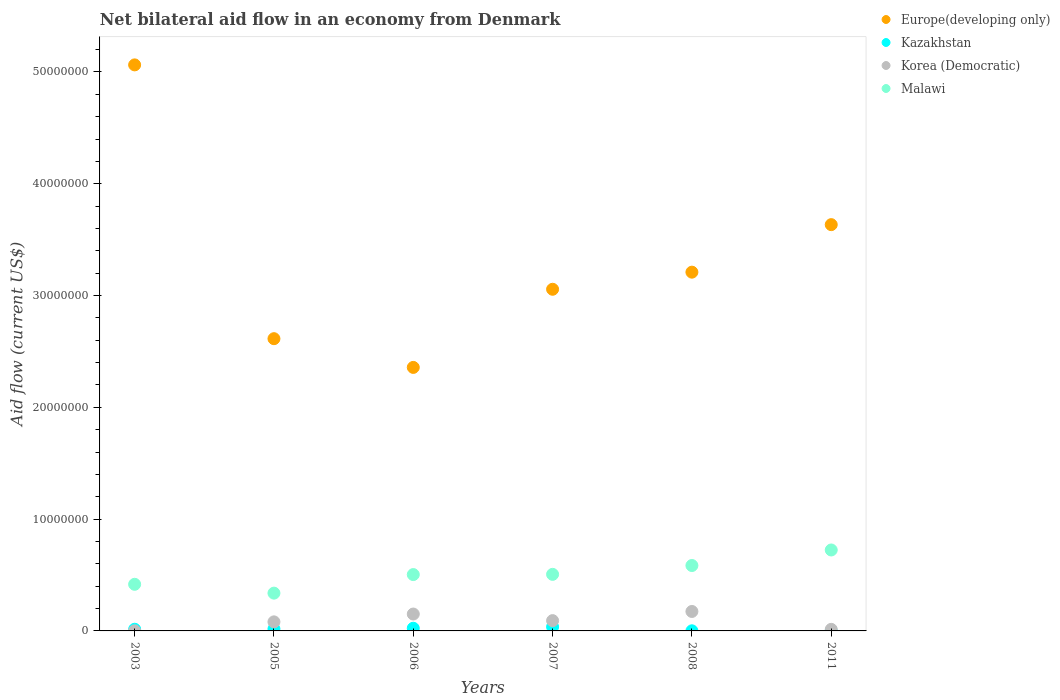What is the net bilateral aid flow in Malawi in 2007?
Your answer should be compact. 5.06e+06. Across all years, what is the maximum net bilateral aid flow in Malawi?
Keep it short and to the point. 7.24e+06. Across all years, what is the minimum net bilateral aid flow in Malawi?
Offer a terse response. 3.38e+06. What is the total net bilateral aid flow in Malawi in the graph?
Your answer should be compact. 3.07e+07. What is the difference between the net bilateral aid flow in Korea (Democratic) in 2003 and that in 2006?
Keep it short and to the point. -1.50e+06. What is the difference between the net bilateral aid flow in Malawi in 2003 and the net bilateral aid flow in Europe(developing only) in 2005?
Make the answer very short. -2.20e+07. What is the average net bilateral aid flow in Korea (Democratic) per year?
Give a very brief answer. 8.55e+05. In the year 2003, what is the difference between the net bilateral aid flow in Europe(developing only) and net bilateral aid flow in Korea (Democratic)?
Ensure brevity in your answer.  5.06e+07. In how many years, is the net bilateral aid flow in Malawi greater than 32000000 US$?
Offer a very short reply. 0. What is the ratio of the net bilateral aid flow in Europe(developing only) in 2006 to that in 2008?
Your answer should be compact. 0.73. Is the net bilateral aid flow in Kazakhstan in 2003 less than that in 2006?
Your response must be concise. Yes. Is the difference between the net bilateral aid flow in Europe(developing only) in 2008 and 2011 greater than the difference between the net bilateral aid flow in Korea (Democratic) in 2008 and 2011?
Your answer should be compact. No. What is the difference between the highest and the second highest net bilateral aid flow in Malawi?
Give a very brief answer. 1.39e+06. What is the difference between the highest and the lowest net bilateral aid flow in Korea (Democratic)?
Provide a short and direct response. 1.73e+06. Is the sum of the net bilateral aid flow in Korea (Democratic) in 2007 and 2008 greater than the maximum net bilateral aid flow in Kazakhstan across all years?
Offer a very short reply. Yes. Is it the case that in every year, the sum of the net bilateral aid flow in Korea (Democratic) and net bilateral aid flow in Malawi  is greater than the net bilateral aid flow in Kazakhstan?
Provide a short and direct response. Yes. How many dotlines are there?
Your answer should be compact. 4. How many years are there in the graph?
Your answer should be very brief. 6. What is the difference between two consecutive major ticks on the Y-axis?
Your answer should be very brief. 1.00e+07. Does the graph contain any zero values?
Keep it short and to the point. Yes. How are the legend labels stacked?
Offer a terse response. Vertical. What is the title of the graph?
Your answer should be compact. Net bilateral aid flow in an economy from Denmark. Does "Suriname" appear as one of the legend labels in the graph?
Make the answer very short. No. What is the label or title of the X-axis?
Provide a short and direct response. Years. What is the label or title of the Y-axis?
Provide a short and direct response. Aid flow (current US$). What is the Aid flow (current US$) of Europe(developing only) in 2003?
Your answer should be very brief. 5.06e+07. What is the Aid flow (current US$) of Malawi in 2003?
Your response must be concise. 4.17e+06. What is the Aid flow (current US$) in Europe(developing only) in 2005?
Offer a very short reply. 2.61e+07. What is the Aid flow (current US$) in Korea (Democratic) in 2005?
Your response must be concise. 8.10e+05. What is the Aid flow (current US$) of Malawi in 2005?
Your answer should be compact. 3.38e+06. What is the Aid flow (current US$) in Europe(developing only) in 2006?
Your answer should be very brief. 2.36e+07. What is the Aid flow (current US$) of Kazakhstan in 2006?
Offer a terse response. 2.40e+05. What is the Aid flow (current US$) of Korea (Democratic) in 2006?
Your response must be concise. 1.51e+06. What is the Aid flow (current US$) in Malawi in 2006?
Your answer should be very brief. 5.04e+06. What is the Aid flow (current US$) of Europe(developing only) in 2007?
Offer a very short reply. 3.06e+07. What is the Aid flow (current US$) of Kazakhstan in 2007?
Offer a very short reply. 3.60e+05. What is the Aid flow (current US$) of Korea (Democratic) in 2007?
Offer a very short reply. 9.20e+05. What is the Aid flow (current US$) of Malawi in 2007?
Make the answer very short. 5.06e+06. What is the Aid flow (current US$) in Europe(developing only) in 2008?
Provide a succinct answer. 3.21e+07. What is the Aid flow (current US$) in Kazakhstan in 2008?
Ensure brevity in your answer.  10000. What is the Aid flow (current US$) in Korea (Democratic) in 2008?
Provide a short and direct response. 1.74e+06. What is the Aid flow (current US$) of Malawi in 2008?
Offer a very short reply. 5.85e+06. What is the Aid flow (current US$) in Europe(developing only) in 2011?
Offer a terse response. 3.63e+07. What is the Aid flow (current US$) of Malawi in 2011?
Your response must be concise. 7.24e+06. Across all years, what is the maximum Aid flow (current US$) of Europe(developing only)?
Offer a terse response. 5.06e+07. Across all years, what is the maximum Aid flow (current US$) of Korea (Democratic)?
Provide a short and direct response. 1.74e+06. Across all years, what is the maximum Aid flow (current US$) in Malawi?
Your answer should be compact. 7.24e+06. Across all years, what is the minimum Aid flow (current US$) in Europe(developing only)?
Give a very brief answer. 2.36e+07. Across all years, what is the minimum Aid flow (current US$) of Kazakhstan?
Your answer should be compact. 0. Across all years, what is the minimum Aid flow (current US$) in Korea (Democratic)?
Offer a terse response. 10000. Across all years, what is the minimum Aid flow (current US$) of Malawi?
Keep it short and to the point. 3.38e+06. What is the total Aid flow (current US$) of Europe(developing only) in the graph?
Ensure brevity in your answer.  1.99e+08. What is the total Aid flow (current US$) of Kazakhstan in the graph?
Make the answer very short. 9.40e+05. What is the total Aid flow (current US$) of Korea (Democratic) in the graph?
Provide a short and direct response. 5.13e+06. What is the total Aid flow (current US$) of Malawi in the graph?
Provide a succinct answer. 3.07e+07. What is the difference between the Aid flow (current US$) of Europe(developing only) in 2003 and that in 2005?
Your response must be concise. 2.45e+07. What is the difference between the Aid flow (current US$) of Korea (Democratic) in 2003 and that in 2005?
Ensure brevity in your answer.  -8.00e+05. What is the difference between the Aid flow (current US$) of Malawi in 2003 and that in 2005?
Your response must be concise. 7.90e+05. What is the difference between the Aid flow (current US$) of Europe(developing only) in 2003 and that in 2006?
Give a very brief answer. 2.71e+07. What is the difference between the Aid flow (current US$) in Korea (Democratic) in 2003 and that in 2006?
Ensure brevity in your answer.  -1.50e+06. What is the difference between the Aid flow (current US$) in Malawi in 2003 and that in 2006?
Provide a short and direct response. -8.70e+05. What is the difference between the Aid flow (current US$) in Europe(developing only) in 2003 and that in 2007?
Offer a terse response. 2.01e+07. What is the difference between the Aid flow (current US$) in Kazakhstan in 2003 and that in 2007?
Your response must be concise. -2.10e+05. What is the difference between the Aid flow (current US$) in Korea (Democratic) in 2003 and that in 2007?
Your answer should be compact. -9.10e+05. What is the difference between the Aid flow (current US$) of Malawi in 2003 and that in 2007?
Provide a succinct answer. -8.90e+05. What is the difference between the Aid flow (current US$) of Europe(developing only) in 2003 and that in 2008?
Provide a short and direct response. 1.85e+07. What is the difference between the Aid flow (current US$) of Kazakhstan in 2003 and that in 2008?
Offer a terse response. 1.40e+05. What is the difference between the Aid flow (current US$) of Korea (Democratic) in 2003 and that in 2008?
Make the answer very short. -1.73e+06. What is the difference between the Aid flow (current US$) in Malawi in 2003 and that in 2008?
Offer a very short reply. -1.68e+06. What is the difference between the Aid flow (current US$) of Europe(developing only) in 2003 and that in 2011?
Your answer should be compact. 1.43e+07. What is the difference between the Aid flow (current US$) in Malawi in 2003 and that in 2011?
Give a very brief answer. -3.07e+06. What is the difference between the Aid flow (current US$) in Europe(developing only) in 2005 and that in 2006?
Give a very brief answer. 2.57e+06. What is the difference between the Aid flow (current US$) of Korea (Democratic) in 2005 and that in 2006?
Provide a short and direct response. -7.00e+05. What is the difference between the Aid flow (current US$) of Malawi in 2005 and that in 2006?
Provide a short and direct response. -1.66e+06. What is the difference between the Aid flow (current US$) of Europe(developing only) in 2005 and that in 2007?
Provide a succinct answer. -4.42e+06. What is the difference between the Aid flow (current US$) in Kazakhstan in 2005 and that in 2007?
Give a very brief answer. -1.80e+05. What is the difference between the Aid flow (current US$) of Malawi in 2005 and that in 2007?
Provide a succinct answer. -1.68e+06. What is the difference between the Aid flow (current US$) in Europe(developing only) in 2005 and that in 2008?
Ensure brevity in your answer.  -5.95e+06. What is the difference between the Aid flow (current US$) in Korea (Democratic) in 2005 and that in 2008?
Your response must be concise. -9.30e+05. What is the difference between the Aid flow (current US$) in Malawi in 2005 and that in 2008?
Ensure brevity in your answer.  -2.47e+06. What is the difference between the Aid flow (current US$) in Europe(developing only) in 2005 and that in 2011?
Your answer should be very brief. -1.02e+07. What is the difference between the Aid flow (current US$) in Korea (Democratic) in 2005 and that in 2011?
Make the answer very short. 6.70e+05. What is the difference between the Aid flow (current US$) in Malawi in 2005 and that in 2011?
Make the answer very short. -3.86e+06. What is the difference between the Aid flow (current US$) of Europe(developing only) in 2006 and that in 2007?
Your answer should be compact. -6.99e+06. What is the difference between the Aid flow (current US$) of Kazakhstan in 2006 and that in 2007?
Give a very brief answer. -1.20e+05. What is the difference between the Aid flow (current US$) in Korea (Democratic) in 2006 and that in 2007?
Give a very brief answer. 5.90e+05. What is the difference between the Aid flow (current US$) of Malawi in 2006 and that in 2007?
Offer a terse response. -2.00e+04. What is the difference between the Aid flow (current US$) in Europe(developing only) in 2006 and that in 2008?
Keep it short and to the point. -8.52e+06. What is the difference between the Aid flow (current US$) of Kazakhstan in 2006 and that in 2008?
Your answer should be compact. 2.30e+05. What is the difference between the Aid flow (current US$) in Korea (Democratic) in 2006 and that in 2008?
Make the answer very short. -2.30e+05. What is the difference between the Aid flow (current US$) of Malawi in 2006 and that in 2008?
Offer a very short reply. -8.10e+05. What is the difference between the Aid flow (current US$) of Europe(developing only) in 2006 and that in 2011?
Your answer should be compact. -1.28e+07. What is the difference between the Aid flow (current US$) of Korea (Democratic) in 2006 and that in 2011?
Provide a succinct answer. 1.37e+06. What is the difference between the Aid flow (current US$) in Malawi in 2006 and that in 2011?
Offer a terse response. -2.20e+06. What is the difference between the Aid flow (current US$) in Europe(developing only) in 2007 and that in 2008?
Keep it short and to the point. -1.53e+06. What is the difference between the Aid flow (current US$) in Kazakhstan in 2007 and that in 2008?
Provide a succinct answer. 3.50e+05. What is the difference between the Aid flow (current US$) of Korea (Democratic) in 2007 and that in 2008?
Ensure brevity in your answer.  -8.20e+05. What is the difference between the Aid flow (current US$) in Malawi in 2007 and that in 2008?
Your answer should be compact. -7.90e+05. What is the difference between the Aid flow (current US$) in Europe(developing only) in 2007 and that in 2011?
Offer a terse response. -5.78e+06. What is the difference between the Aid flow (current US$) in Korea (Democratic) in 2007 and that in 2011?
Give a very brief answer. 7.80e+05. What is the difference between the Aid flow (current US$) in Malawi in 2007 and that in 2011?
Provide a short and direct response. -2.18e+06. What is the difference between the Aid flow (current US$) in Europe(developing only) in 2008 and that in 2011?
Make the answer very short. -4.25e+06. What is the difference between the Aid flow (current US$) of Korea (Democratic) in 2008 and that in 2011?
Your answer should be compact. 1.60e+06. What is the difference between the Aid flow (current US$) of Malawi in 2008 and that in 2011?
Make the answer very short. -1.39e+06. What is the difference between the Aid flow (current US$) in Europe(developing only) in 2003 and the Aid flow (current US$) in Kazakhstan in 2005?
Offer a very short reply. 5.04e+07. What is the difference between the Aid flow (current US$) of Europe(developing only) in 2003 and the Aid flow (current US$) of Korea (Democratic) in 2005?
Your answer should be compact. 4.98e+07. What is the difference between the Aid flow (current US$) of Europe(developing only) in 2003 and the Aid flow (current US$) of Malawi in 2005?
Your response must be concise. 4.72e+07. What is the difference between the Aid flow (current US$) of Kazakhstan in 2003 and the Aid flow (current US$) of Korea (Democratic) in 2005?
Offer a very short reply. -6.60e+05. What is the difference between the Aid flow (current US$) of Kazakhstan in 2003 and the Aid flow (current US$) of Malawi in 2005?
Keep it short and to the point. -3.23e+06. What is the difference between the Aid flow (current US$) of Korea (Democratic) in 2003 and the Aid flow (current US$) of Malawi in 2005?
Your answer should be compact. -3.37e+06. What is the difference between the Aid flow (current US$) of Europe(developing only) in 2003 and the Aid flow (current US$) of Kazakhstan in 2006?
Make the answer very short. 5.04e+07. What is the difference between the Aid flow (current US$) in Europe(developing only) in 2003 and the Aid flow (current US$) in Korea (Democratic) in 2006?
Provide a short and direct response. 4.91e+07. What is the difference between the Aid flow (current US$) of Europe(developing only) in 2003 and the Aid flow (current US$) of Malawi in 2006?
Make the answer very short. 4.56e+07. What is the difference between the Aid flow (current US$) of Kazakhstan in 2003 and the Aid flow (current US$) of Korea (Democratic) in 2006?
Give a very brief answer. -1.36e+06. What is the difference between the Aid flow (current US$) in Kazakhstan in 2003 and the Aid flow (current US$) in Malawi in 2006?
Give a very brief answer. -4.89e+06. What is the difference between the Aid flow (current US$) of Korea (Democratic) in 2003 and the Aid flow (current US$) of Malawi in 2006?
Keep it short and to the point. -5.03e+06. What is the difference between the Aid flow (current US$) of Europe(developing only) in 2003 and the Aid flow (current US$) of Kazakhstan in 2007?
Keep it short and to the point. 5.03e+07. What is the difference between the Aid flow (current US$) in Europe(developing only) in 2003 and the Aid flow (current US$) in Korea (Democratic) in 2007?
Give a very brief answer. 4.97e+07. What is the difference between the Aid flow (current US$) of Europe(developing only) in 2003 and the Aid flow (current US$) of Malawi in 2007?
Your answer should be compact. 4.56e+07. What is the difference between the Aid flow (current US$) of Kazakhstan in 2003 and the Aid flow (current US$) of Korea (Democratic) in 2007?
Your answer should be compact. -7.70e+05. What is the difference between the Aid flow (current US$) of Kazakhstan in 2003 and the Aid flow (current US$) of Malawi in 2007?
Offer a very short reply. -4.91e+06. What is the difference between the Aid flow (current US$) in Korea (Democratic) in 2003 and the Aid flow (current US$) in Malawi in 2007?
Offer a terse response. -5.05e+06. What is the difference between the Aid flow (current US$) in Europe(developing only) in 2003 and the Aid flow (current US$) in Kazakhstan in 2008?
Offer a terse response. 5.06e+07. What is the difference between the Aid flow (current US$) in Europe(developing only) in 2003 and the Aid flow (current US$) in Korea (Democratic) in 2008?
Your response must be concise. 4.89e+07. What is the difference between the Aid flow (current US$) in Europe(developing only) in 2003 and the Aid flow (current US$) in Malawi in 2008?
Provide a short and direct response. 4.48e+07. What is the difference between the Aid flow (current US$) in Kazakhstan in 2003 and the Aid flow (current US$) in Korea (Democratic) in 2008?
Your answer should be compact. -1.59e+06. What is the difference between the Aid flow (current US$) in Kazakhstan in 2003 and the Aid flow (current US$) in Malawi in 2008?
Keep it short and to the point. -5.70e+06. What is the difference between the Aid flow (current US$) in Korea (Democratic) in 2003 and the Aid flow (current US$) in Malawi in 2008?
Your answer should be compact. -5.84e+06. What is the difference between the Aid flow (current US$) of Europe(developing only) in 2003 and the Aid flow (current US$) of Korea (Democratic) in 2011?
Your answer should be very brief. 5.05e+07. What is the difference between the Aid flow (current US$) in Europe(developing only) in 2003 and the Aid flow (current US$) in Malawi in 2011?
Provide a succinct answer. 4.34e+07. What is the difference between the Aid flow (current US$) of Kazakhstan in 2003 and the Aid flow (current US$) of Korea (Democratic) in 2011?
Offer a terse response. 10000. What is the difference between the Aid flow (current US$) of Kazakhstan in 2003 and the Aid flow (current US$) of Malawi in 2011?
Keep it short and to the point. -7.09e+06. What is the difference between the Aid flow (current US$) in Korea (Democratic) in 2003 and the Aid flow (current US$) in Malawi in 2011?
Ensure brevity in your answer.  -7.23e+06. What is the difference between the Aid flow (current US$) of Europe(developing only) in 2005 and the Aid flow (current US$) of Kazakhstan in 2006?
Give a very brief answer. 2.59e+07. What is the difference between the Aid flow (current US$) of Europe(developing only) in 2005 and the Aid flow (current US$) of Korea (Democratic) in 2006?
Your response must be concise. 2.46e+07. What is the difference between the Aid flow (current US$) in Europe(developing only) in 2005 and the Aid flow (current US$) in Malawi in 2006?
Make the answer very short. 2.11e+07. What is the difference between the Aid flow (current US$) of Kazakhstan in 2005 and the Aid flow (current US$) of Korea (Democratic) in 2006?
Offer a very short reply. -1.33e+06. What is the difference between the Aid flow (current US$) in Kazakhstan in 2005 and the Aid flow (current US$) in Malawi in 2006?
Make the answer very short. -4.86e+06. What is the difference between the Aid flow (current US$) in Korea (Democratic) in 2005 and the Aid flow (current US$) in Malawi in 2006?
Your answer should be very brief. -4.23e+06. What is the difference between the Aid flow (current US$) of Europe(developing only) in 2005 and the Aid flow (current US$) of Kazakhstan in 2007?
Keep it short and to the point. 2.58e+07. What is the difference between the Aid flow (current US$) of Europe(developing only) in 2005 and the Aid flow (current US$) of Korea (Democratic) in 2007?
Your answer should be very brief. 2.52e+07. What is the difference between the Aid flow (current US$) of Europe(developing only) in 2005 and the Aid flow (current US$) of Malawi in 2007?
Your answer should be very brief. 2.11e+07. What is the difference between the Aid flow (current US$) of Kazakhstan in 2005 and the Aid flow (current US$) of Korea (Democratic) in 2007?
Your answer should be compact. -7.40e+05. What is the difference between the Aid flow (current US$) in Kazakhstan in 2005 and the Aid flow (current US$) in Malawi in 2007?
Keep it short and to the point. -4.88e+06. What is the difference between the Aid flow (current US$) in Korea (Democratic) in 2005 and the Aid flow (current US$) in Malawi in 2007?
Provide a short and direct response. -4.25e+06. What is the difference between the Aid flow (current US$) in Europe(developing only) in 2005 and the Aid flow (current US$) in Kazakhstan in 2008?
Provide a succinct answer. 2.61e+07. What is the difference between the Aid flow (current US$) in Europe(developing only) in 2005 and the Aid flow (current US$) in Korea (Democratic) in 2008?
Give a very brief answer. 2.44e+07. What is the difference between the Aid flow (current US$) in Europe(developing only) in 2005 and the Aid flow (current US$) in Malawi in 2008?
Offer a very short reply. 2.03e+07. What is the difference between the Aid flow (current US$) of Kazakhstan in 2005 and the Aid flow (current US$) of Korea (Democratic) in 2008?
Provide a short and direct response. -1.56e+06. What is the difference between the Aid flow (current US$) in Kazakhstan in 2005 and the Aid flow (current US$) in Malawi in 2008?
Provide a short and direct response. -5.67e+06. What is the difference between the Aid flow (current US$) of Korea (Democratic) in 2005 and the Aid flow (current US$) of Malawi in 2008?
Offer a terse response. -5.04e+06. What is the difference between the Aid flow (current US$) in Europe(developing only) in 2005 and the Aid flow (current US$) in Korea (Democratic) in 2011?
Offer a very short reply. 2.60e+07. What is the difference between the Aid flow (current US$) in Europe(developing only) in 2005 and the Aid flow (current US$) in Malawi in 2011?
Provide a short and direct response. 1.89e+07. What is the difference between the Aid flow (current US$) in Kazakhstan in 2005 and the Aid flow (current US$) in Malawi in 2011?
Give a very brief answer. -7.06e+06. What is the difference between the Aid flow (current US$) of Korea (Democratic) in 2005 and the Aid flow (current US$) of Malawi in 2011?
Your answer should be very brief. -6.43e+06. What is the difference between the Aid flow (current US$) of Europe(developing only) in 2006 and the Aid flow (current US$) of Kazakhstan in 2007?
Ensure brevity in your answer.  2.32e+07. What is the difference between the Aid flow (current US$) of Europe(developing only) in 2006 and the Aid flow (current US$) of Korea (Democratic) in 2007?
Keep it short and to the point. 2.26e+07. What is the difference between the Aid flow (current US$) in Europe(developing only) in 2006 and the Aid flow (current US$) in Malawi in 2007?
Your answer should be very brief. 1.85e+07. What is the difference between the Aid flow (current US$) in Kazakhstan in 2006 and the Aid flow (current US$) in Korea (Democratic) in 2007?
Your answer should be compact. -6.80e+05. What is the difference between the Aid flow (current US$) in Kazakhstan in 2006 and the Aid flow (current US$) in Malawi in 2007?
Your answer should be compact. -4.82e+06. What is the difference between the Aid flow (current US$) in Korea (Democratic) in 2006 and the Aid flow (current US$) in Malawi in 2007?
Ensure brevity in your answer.  -3.55e+06. What is the difference between the Aid flow (current US$) of Europe(developing only) in 2006 and the Aid flow (current US$) of Kazakhstan in 2008?
Make the answer very short. 2.36e+07. What is the difference between the Aid flow (current US$) of Europe(developing only) in 2006 and the Aid flow (current US$) of Korea (Democratic) in 2008?
Offer a very short reply. 2.18e+07. What is the difference between the Aid flow (current US$) of Europe(developing only) in 2006 and the Aid flow (current US$) of Malawi in 2008?
Your answer should be compact. 1.77e+07. What is the difference between the Aid flow (current US$) of Kazakhstan in 2006 and the Aid flow (current US$) of Korea (Democratic) in 2008?
Your answer should be very brief. -1.50e+06. What is the difference between the Aid flow (current US$) of Kazakhstan in 2006 and the Aid flow (current US$) of Malawi in 2008?
Ensure brevity in your answer.  -5.61e+06. What is the difference between the Aid flow (current US$) of Korea (Democratic) in 2006 and the Aid flow (current US$) of Malawi in 2008?
Ensure brevity in your answer.  -4.34e+06. What is the difference between the Aid flow (current US$) in Europe(developing only) in 2006 and the Aid flow (current US$) in Korea (Democratic) in 2011?
Offer a terse response. 2.34e+07. What is the difference between the Aid flow (current US$) of Europe(developing only) in 2006 and the Aid flow (current US$) of Malawi in 2011?
Provide a short and direct response. 1.63e+07. What is the difference between the Aid flow (current US$) of Kazakhstan in 2006 and the Aid flow (current US$) of Korea (Democratic) in 2011?
Your answer should be very brief. 1.00e+05. What is the difference between the Aid flow (current US$) in Kazakhstan in 2006 and the Aid flow (current US$) in Malawi in 2011?
Offer a very short reply. -7.00e+06. What is the difference between the Aid flow (current US$) of Korea (Democratic) in 2006 and the Aid flow (current US$) of Malawi in 2011?
Provide a short and direct response. -5.73e+06. What is the difference between the Aid flow (current US$) in Europe(developing only) in 2007 and the Aid flow (current US$) in Kazakhstan in 2008?
Provide a short and direct response. 3.06e+07. What is the difference between the Aid flow (current US$) of Europe(developing only) in 2007 and the Aid flow (current US$) of Korea (Democratic) in 2008?
Ensure brevity in your answer.  2.88e+07. What is the difference between the Aid flow (current US$) of Europe(developing only) in 2007 and the Aid flow (current US$) of Malawi in 2008?
Make the answer very short. 2.47e+07. What is the difference between the Aid flow (current US$) of Kazakhstan in 2007 and the Aid flow (current US$) of Korea (Democratic) in 2008?
Your response must be concise. -1.38e+06. What is the difference between the Aid flow (current US$) in Kazakhstan in 2007 and the Aid flow (current US$) in Malawi in 2008?
Provide a short and direct response. -5.49e+06. What is the difference between the Aid flow (current US$) in Korea (Democratic) in 2007 and the Aid flow (current US$) in Malawi in 2008?
Make the answer very short. -4.93e+06. What is the difference between the Aid flow (current US$) in Europe(developing only) in 2007 and the Aid flow (current US$) in Korea (Democratic) in 2011?
Offer a very short reply. 3.04e+07. What is the difference between the Aid flow (current US$) in Europe(developing only) in 2007 and the Aid flow (current US$) in Malawi in 2011?
Your answer should be compact. 2.33e+07. What is the difference between the Aid flow (current US$) of Kazakhstan in 2007 and the Aid flow (current US$) of Korea (Democratic) in 2011?
Your answer should be very brief. 2.20e+05. What is the difference between the Aid flow (current US$) of Kazakhstan in 2007 and the Aid flow (current US$) of Malawi in 2011?
Your answer should be compact. -6.88e+06. What is the difference between the Aid flow (current US$) of Korea (Democratic) in 2007 and the Aid flow (current US$) of Malawi in 2011?
Your answer should be compact. -6.32e+06. What is the difference between the Aid flow (current US$) of Europe(developing only) in 2008 and the Aid flow (current US$) of Korea (Democratic) in 2011?
Keep it short and to the point. 3.20e+07. What is the difference between the Aid flow (current US$) in Europe(developing only) in 2008 and the Aid flow (current US$) in Malawi in 2011?
Provide a short and direct response. 2.48e+07. What is the difference between the Aid flow (current US$) in Kazakhstan in 2008 and the Aid flow (current US$) in Korea (Democratic) in 2011?
Your answer should be compact. -1.30e+05. What is the difference between the Aid flow (current US$) in Kazakhstan in 2008 and the Aid flow (current US$) in Malawi in 2011?
Ensure brevity in your answer.  -7.23e+06. What is the difference between the Aid flow (current US$) of Korea (Democratic) in 2008 and the Aid flow (current US$) of Malawi in 2011?
Ensure brevity in your answer.  -5.50e+06. What is the average Aid flow (current US$) of Europe(developing only) per year?
Your answer should be very brief. 3.32e+07. What is the average Aid flow (current US$) in Kazakhstan per year?
Ensure brevity in your answer.  1.57e+05. What is the average Aid flow (current US$) of Korea (Democratic) per year?
Provide a succinct answer. 8.55e+05. What is the average Aid flow (current US$) in Malawi per year?
Your answer should be very brief. 5.12e+06. In the year 2003, what is the difference between the Aid flow (current US$) in Europe(developing only) and Aid flow (current US$) in Kazakhstan?
Ensure brevity in your answer.  5.05e+07. In the year 2003, what is the difference between the Aid flow (current US$) in Europe(developing only) and Aid flow (current US$) in Korea (Democratic)?
Make the answer very short. 5.06e+07. In the year 2003, what is the difference between the Aid flow (current US$) of Europe(developing only) and Aid flow (current US$) of Malawi?
Your answer should be compact. 4.65e+07. In the year 2003, what is the difference between the Aid flow (current US$) of Kazakhstan and Aid flow (current US$) of Korea (Democratic)?
Your answer should be compact. 1.40e+05. In the year 2003, what is the difference between the Aid flow (current US$) of Kazakhstan and Aid flow (current US$) of Malawi?
Make the answer very short. -4.02e+06. In the year 2003, what is the difference between the Aid flow (current US$) of Korea (Democratic) and Aid flow (current US$) of Malawi?
Give a very brief answer. -4.16e+06. In the year 2005, what is the difference between the Aid flow (current US$) in Europe(developing only) and Aid flow (current US$) in Kazakhstan?
Offer a very short reply. 2.60e+07. In the year 2005, what is the difference between the Aid flow (current US$) of Europe(developing only) and Aid flow (current US$) of Korea (Democratic)?
Make the answer very short. 2.53e+07. In the year 2005, what is the difference between the Aid flow (current US$) in Europe(developing only) and Aid flow (current US$) in Malawi?
Your answer should be very brief. 2.28e+07. In the year 2005, what is the difference between the Aid flow (current US$) of Kazakhstan and Aid flow (current US$) of Korea (Democratic)?
Ensure brevity in your answer.  -6.30e+05. In the year 2005, what is the difference between the Aid flow (current US$) in Kazakhstan and Aid flow (current US$) in Malawi?
Provide a short and direct response. -3.20e+06. In the year 2005, what is the difference between the Aid flow (current US$) of Korea (Democratic) and Aid flow (current US$) of Malawi?
Your answer should be compact. -2.57e+06. In the year 2006, what is the difference between the Aid flow (current US$) of Europe(developing only) and Aid flow (current US$) of Kazakhstan?
Give a very brief answer. 2.33e+07. In the year 2006, what is the difference between the Aid flow (current US$) of Europe(developing only) and Aid flow (current US$) of Korea (Democratic)?
Offer a very short reply. 2.21e+07. In the year 2006, what is the difference between the Aid flow (current US$) in Europe(developing only) and Aid flow (current US$) in Malawi?
Your answer should be very brief. 1.85e+07. In the year 2006, what is the difference between the Aid flow (current US$) in Kazakhstan and Aid flow (current US$) in Korea (Democratic)?
Give a very brief answer. -1.27e+06. In the year 2006, what is the difference between the Aid flow (current US$) of Kazakhstan and Aid flow (current US$) of Malawi?
Provide a short and direct response. -4.80e+06. In the year 2006, what is the difference between the Aid flow (current US$) in Korea (Democratic) and Aid flow (current US$) in Malawi?
Your response must be concise. -3.53e+06. In the year 2007, what is the difference between the Aid flow (current US$) of Europe(developing only) and Aid flow (current US$) of Kazakhstan?
Ensure brevity in your answer.  3.02e+07. In the year 2007, what is the difference between the Aid flow (current US$) in Europe(developing only) and Aid flow (current US$) in Korea (Democratic)?
Your answer should be compact. 2.96e+07. In the year 2007, what is the difference between the Aid flow (current US$) of Europe(developing only) and Aid flow (current US$) of Malawi?
Provide a short and direct response. 2.55e+07. In the year 2007, what is the difference between the Aid flow (current US$) in Kazakhstan and Aid flow (current US$) in Korea (Democratic)?
Make the answer very short. -5.60e+05. In the year 2007, what is the difference between the Aid flow (current US$) in Kazakhstan and Aid flow (current US$) in Malawi?
Ensure brevity in your answer.  -4.70e+06. In the year 2007, what is the difference between the Aid flow (current US$) in Korea (Democratic) and Aid flow (current US$) in Malawi?
Keep it short and to the point. -4.14e+06. In the year 2008, what is the difference between the Aid flow (current US$) of Europe(developing only) and Aid flow (current US$) of Kazakhstan?
Keep it short and to the point. 3.21e+07. In the year 2008, what is the difference between the Aid flow (current US$) in Europe(developing only) and Aid flow (current US$) in Korea (Democratic)?
Your answer should be compact. 3.04e+07. In the year 2008, what is the difference between the Aid flow (current US$) of Europe(developing only) and Aid flow (current US$) of Malawi?
Provide a short and direct response. 2.62e+07. In the year 2008, what is the difference between the Aid flow (current US$) in Kazakhstan and Aid flow (current US$) in Korea (Democratic)?
Offer a very short reply. -1.73e+06. In the year 2008, what is the difference between the Aid flow (current US$) in Kazakhstan and Aid flow (current US$) in Malawi?
Offer a terse response. -5.84e+06. In the year 2008, what is the difference between the Aid flow (current US$) of Korea (Democratic) and Aid flow (current US$) of Malawi?
Make the answer very short. -4.11e+06. In the year 2011, what is the difference between the Aid flow (current US$) in Europe(developing only) and Aid flow (current US$) in Korea (Democratic)?
Give a very brief answer. 3.62e+07. In the year 2011, what is the difference between the Aid flow (current US$) of Europe(developing only) and Aid flow (current US$) of Malawi?
Provide a short and direct response. 2.91e+07. In the year 2011, what is the difference between the Aid flow (current US$) in Korea (Democratic) and Aid flow (current US$) in Malawi?
Your response must be concise. -7.10e+06. What is the ratio of the Aid flow (current US$) of Europe(developing only) in 2003 to that in 2005?
Your response must be concise. 1.94. What is the ratio of the Aid flow (current US$) of Korea (Democratic) in 2003 to that in 2005?
Make the answer very short. 0.01. What is the ratio of the Aid flow (current US$) in Malawi in 2003 to that in 2005?
Keep it short and to the point. 1.23. What is the ratio of the Aid flow (current US$) of Europe(developing only) in 2003 to that in 2006?
Give a very brief answer. 2.15. What is the ratio of the Aid flow (current US$) of Kazakhstan in 2003 to that in 2006?
Provide a succinct answer. 0.62. What is the ratio of the Aid flow (current US$) in Korea (Democratic) in 2003 to that in 2006?
Give a very brief answer. 0.01. What is the ratio of the Aid flow (current US$) of Malawi in 2003 to that in 2006?
Keep it short and to the point. 0.83. What is the ratio of the Aid flow (current US$) of Europe(developing only) in 2003 to that in 2007?
Ensure brevity in your answer.  1.66. What is the ratio of the Aid flow (current US$) of Kazakhstan in 2003 to that in 2007?
Provide a short and direct response. 0.42. What is the ratio of the Aid flow (current US$) in Korea (Democratic) in 2003 to that in 2007?
Ensure brevity in your answer.  0.01. What is the ratio of the Aid flow (current US$) in Malawi in 2003 to that in 2007?
Your response must be concise. 0.82. What is the ratio of the Aid flow (current US$) in Europe(developing only) in 2003 to that in 2008?
Make the answer very short. 1.58. What is the ratio of the Aid flow (current US$) of Kazakhstan in 2003 to that in 2008?
Offer a very short reply. 15. What is the ratio of the Aid flow (current US$) of Korea (Democratic) in 2003 to that in 2008?
Offer a very short reply. 0.01. What is the ratio of the Aid flow (current US$) of Malawi in 2003 to that in 2008?
Your response must be concise. 0.71. What is the ratio of the Aid flow (current US$) in Europe(developing only) in 2003 to that in 2011?
Your answer should be compact. 1.39. What is the ratio of the Aid flow (current US$) of Korea (Democratic) in 2003 to that in 2011?
Your answer should be very brief. 0.07. What is the ratio of the Aid flow (current US$) of Malawi in 2003 to that in 2011?
Provide a short and direct response. 0.58. What is the ratio of the Aid flow (current US$) of Europe(developing only) in 2005 to that in 2006?
Ensure brevity in your answer.  1.11. What is the ratio of the Aid flow (current US$) in Korea (Democratic) in 2005 to that in 2006?
Keep it short and to the point. 0.54. What is the ratio of the Aid flow (current US$) of Malawi in 2005 to that in 2006?
Provide a succinct answer. 0.67. What is the ratio of the Aid flow (current US$) of Europe(developing only) in 2005 to that in 2007?
Provide a short and direct response. 0.86. What is the ratio of the Aid flow (current US$) of Kazakhstan in 2005 to that in 2007?
Offer a terse response. 0.5. What is the ratio of the Aid flow (current US$) in Korea (Democratic) in 2005 to that in 2007?
Provide a short and direct response. 0.88. What is the ratio of the Aid flow (current US$) of Malawi in 2005 to that in 2007?
Make the answer very short. 0.67. What is the ratio of the Aid flow (current US$) in Europe(developing only) in 2005 to that in 2008?
Your response must be concise. 0.81. What is the ratio of the Aid flow (current US$) of Kazakhstan in 2005 to that in 2008?
Keep it short and to the point. 18. What is the ratio of the Aid flow (current US$) of Korea (Democratic) in 2005 to that in 2008?
Your answer should be very brief. 0.47. What is the ratio of the Aid flow (current US$) in Malawi in 2005 to that in 2008?
Your answer should be compact. 0.58. What is the ratio of the Aid flow (current US$) in Europe(developing only) in 2005 to that in 2011?
Ensure brevity in your answer.  0.72. What is the ratio of the Aid flow (current US$) in Korea (Democratic) in 2005 to that in 2011?
Offer a very short reply. 5.79. What is the ratio of the Aid flow (current US$) of Malawi in 2005 to that in 2011?
Your answer should be very brief. 0.47. What is the ratio of the Aid flow (current US$) of Europe(developing only) in 2006 to that in 2007?
Provide a succinct answer. 0.77. What is the ratio of the Aid flow (current US$) of Kazakhstan in 2006 to that in 2007?
Ensure brevity in your answer.  0.67. What is the ratio of the Aid flow (current US$) in Korea (Democratic) in 2006 to that in 2007?
Your answer should be very brief. 1.64. What is the ratio of the Aid flow (current US$) in Malawi in 2006 to that in 2007?
Keep it short and to the point. 1. What is the ratio of the Aid flow (current US$) in Europe(developing only) in 2006 to that in 2008?
Make the answer very short. 0.73. What is the ratio of the Aid flow (current US$) in Korea (Democratic) in 2006 to that in 2008?
Make the answer very short. 0.87. What is the ratio of the Aid flow (current US$) in Malawi in 2006 to that in 2008?
Provide a short and direct response. 0.86. What is the ratio of the Aid flow (current US$) of Europe(developing only) in 2006 to that in 2011?
Offer a terse response. 0.65. What is the ratio of the Aid flow (current US$) in Korea (Democratic) in 2006 to that in 2011?
Provide a short and direct response. 10.79. What is the ratio of the Aid flow (current US$) in Malawi in 2006 to that in 2011?
Your response must be concise. 0.7. What is the ratio of the Aid flow (current US$) of Europe(developing only) in 2007 to that in 2008?
Your answer should be compact. 0.95. What is the ratio of the Aid flow (current US$) in Korea (Democratic) in 2007 to that in 2008?
Give a very brief answer. 0.53. What is the ratio of the Aid flow (current US$) in Malawi in 2007 to that in 2008?
Give a very brief answer. 0.86. What is the ratio of the Aid flow (current US$) of Europe(developing only) in 2007 to that in 2011?
Give a very brief answer. 0.84. What is the ratio of the Aid flow (current US$) in Korea (Democratic) in 2007 to that in 2011?
Make the answer very short. 6.57. What is the ratio of the Aid flow (current US$) in Malawi in 2007 to that in 2011?
Give a very brief answer. 0.7. What is the ratio of the Aid flow (current US$) in Europe(developing only) in 2008 to that in 2011?
Keep it short and to the point. 0.88. What is the ratio of the Aid flow (current US$) in Korea (Democratic) in 2008 to that in 2011?
Offer a very short reply. 12.43. What is the ratio of the Aid flow (current US$) in Malawi in 2008 to that in 2011?
Offer a very short reply. 0.81. What is the difference between the highest and the second highest Aid flow (current US$) of Europe(developing only)?
Ensure brevity in your answer.  1.43e+07. What is the difference between the highest and the second highest Aid flow (current US$) of Korea (Democratic)?
Your answer should be compact. 2.30e+05. What is the difference between the highest and the second highest Aid flow (current US$) of Malawi?
Your answer should be compact. 1.39e+06. What is the difference between the highest and the lowest Aid flow (current US$) in Europe(developing only)?
Provide a succinct answer. 2.71e+07. What is the difference between the highest and the lowest Aid flow (current US$) of Korea (Democratic)?
Offer a terse response. 1.73e+06. What is the difference between the highest and the lowest Aid flow (current US$) in Malawi?
Offer a very short reply. 3.86e+06. 